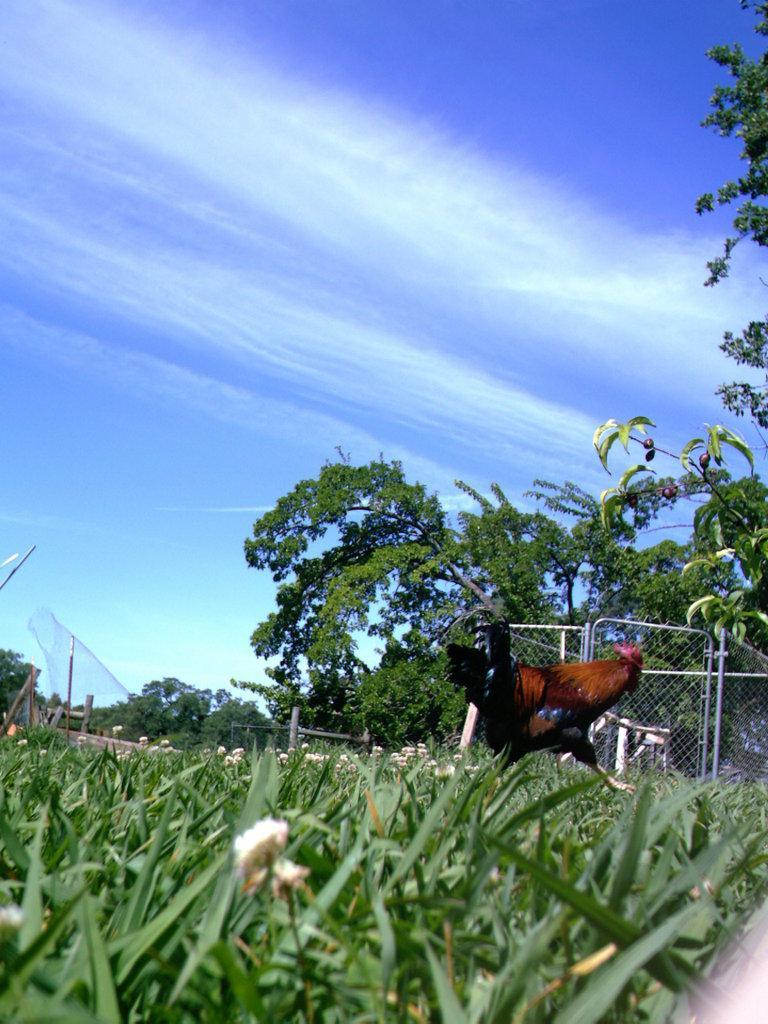Please provide a concise description of this image. In this picture we can see the brown rooster running on the grass. Behind there is a fencing grill net and some trees. In the front bottom side there is grass. On the top there is a sky and clouds. 